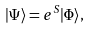<formula> <loc_0><loc_0><loc_500><loc_500>| \Psi \rangle = e ^ { S } | \Phi \rangle ,</formula> 